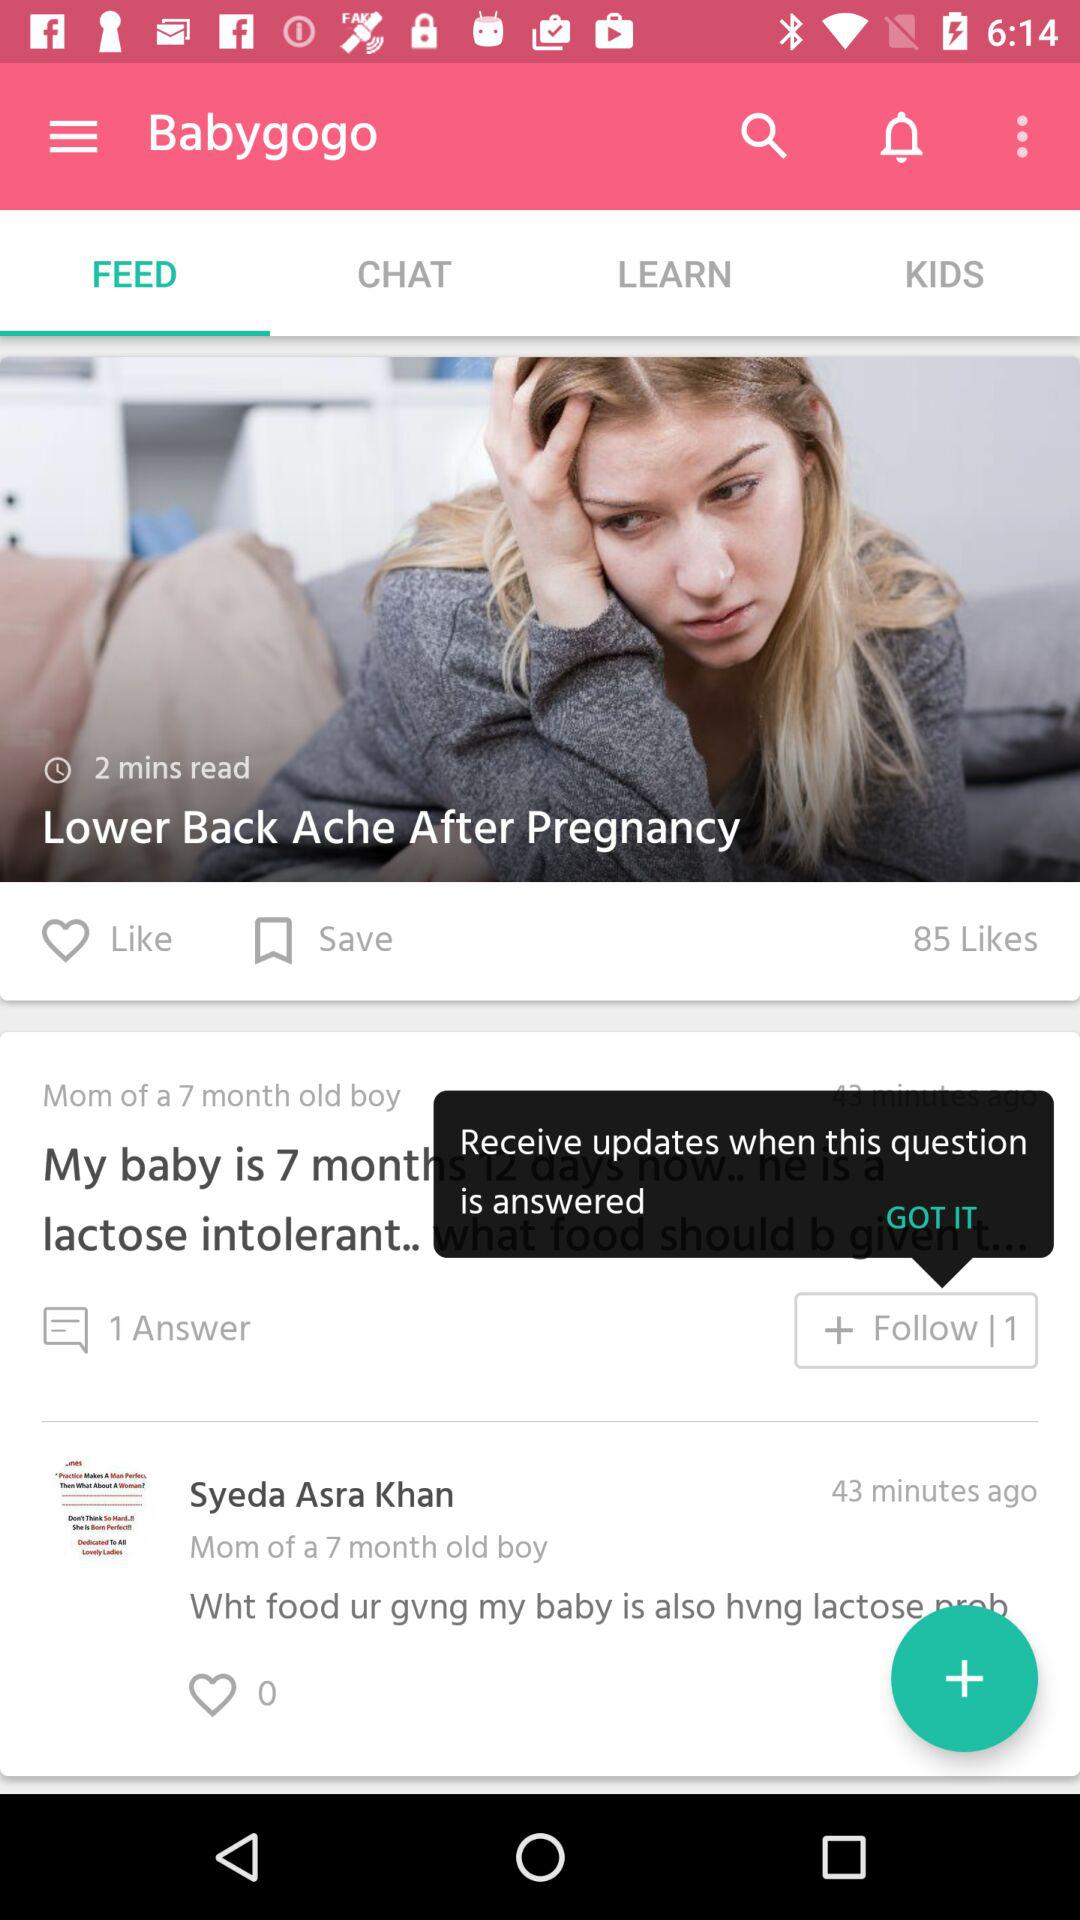How many likes does the post have?
Answer the question using a single word or phrase. 85 